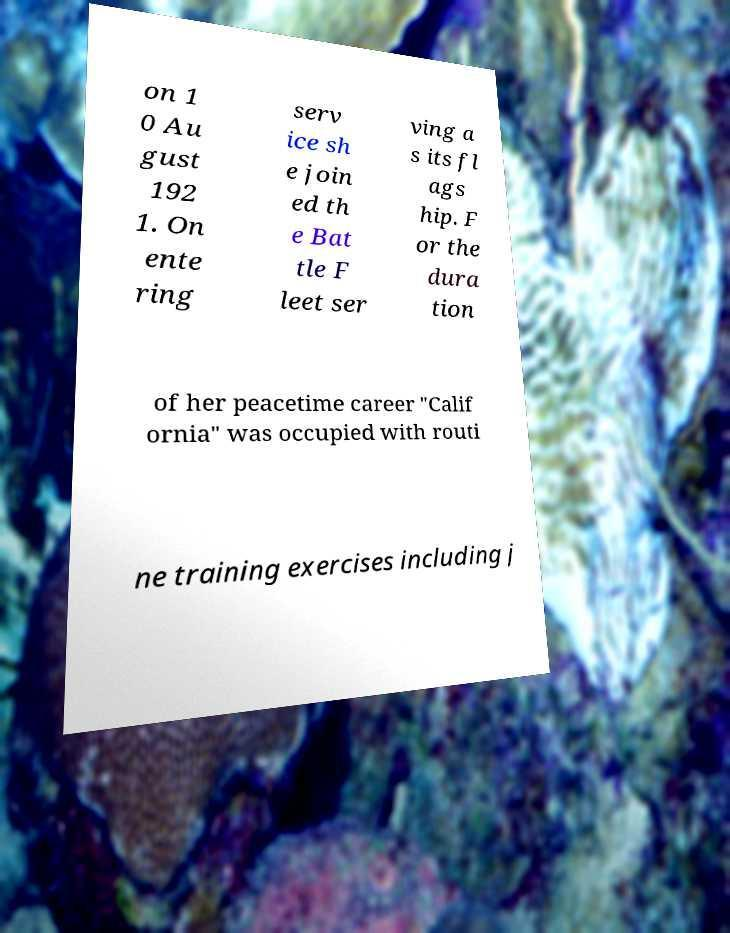What messages or text are displayed in this image? I need them in a readable, typed format. on 1 0 Au gust 192 1. On ente ring serv ice sh e join ed th e Bat tle F leet ser ving a s its fl ags hip. F or the dura tion of her peacetime career "Calif ornia" was occupied with routi ne training exercises including j 